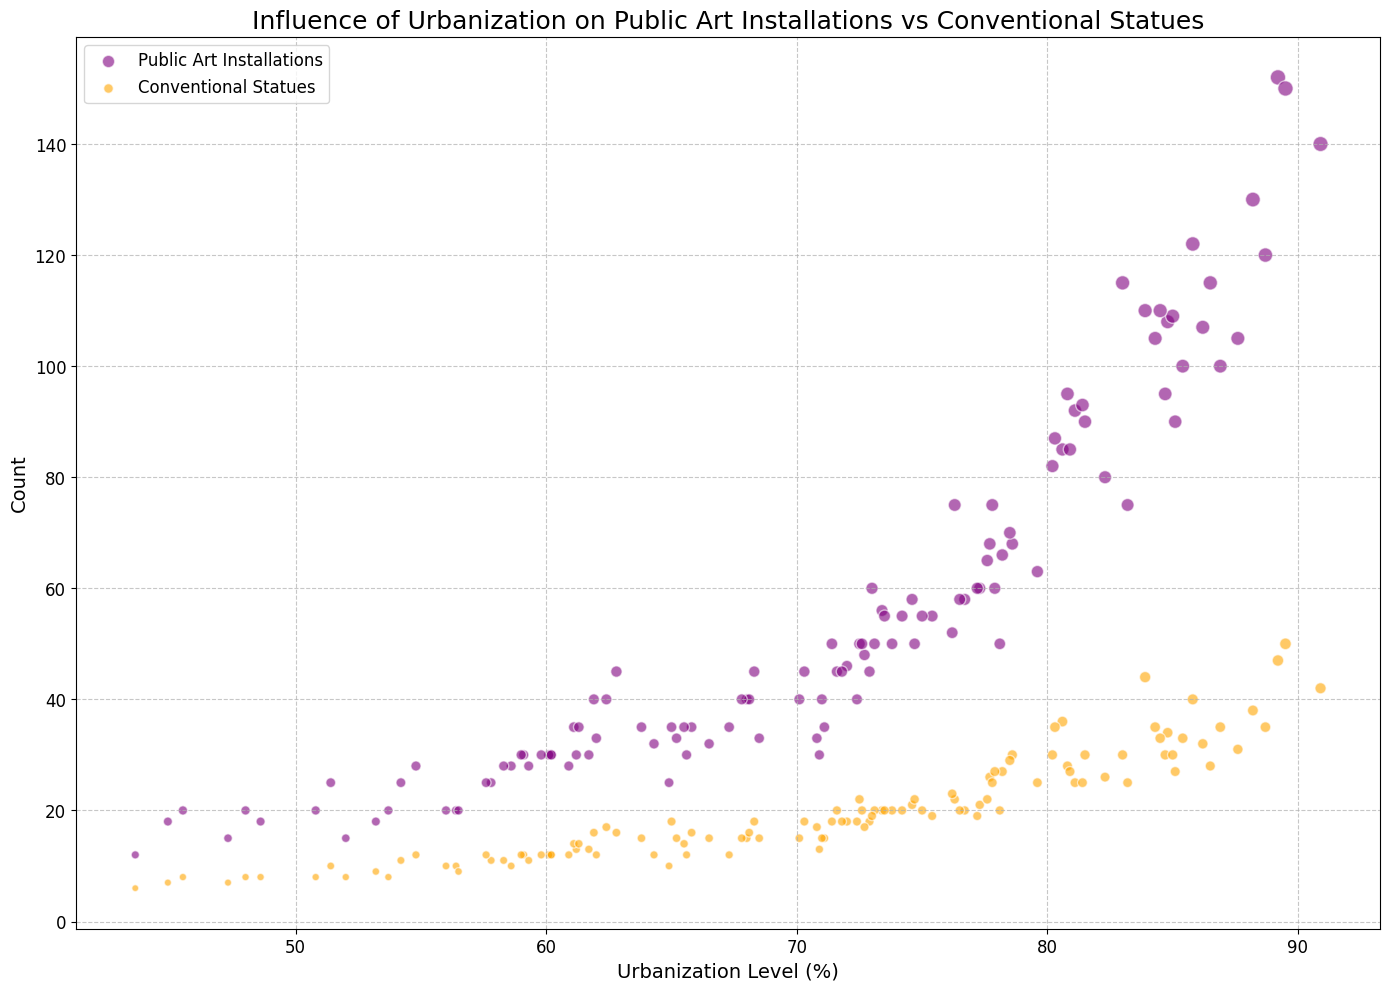What is the general trend between urbanization level and the number of public art installations? Most cities with higher urbanization levels tend to have a higher number of public art installations. For instance, cities like New York and San Francisco show both high urbanization levels and a significant number of public art installations.
Answer: Higher urbanization corresponds to more public art installations Which city has the highest number of conventional statues and what is its urbanization level? Washington DC has the highest number of conventional statues at 50. Its urbanization level is 89.5%.
Answer: Washington DC; 89.5% How do the sizes of the art and statue markers vary with their respective number of installations/statues? The markers' sizes are proportional to the square root of the number of installations/statues. Hence, a higher number results in larger markers. Public art installations markers are purple, and conventional statues markers are orange.
Answer: Proportional to the square root Which city with an urbanization level over 85% has the lowest number of public art installations, and how many does it have? San Diego has the lowest number of public art installations among cities with an urbanization level over 85%, with 90 installations.
Answer: San Diego; 90 Compare New York and Phoenix in terms of urbanization level and the number of public art installations. Which city has a higher urbanization level and more installations? New York has a higher urbanization level (89.2%) and more public art installations (152) compared to Phoenix, which has an urbanization level of 81.1% and 92 installations.
Answer: New York What is the average number of conventional statues in cities with urbanization levels between 80% and 85%? Calculating the average: Philadelphia (36), Dallas (30), San Jose (31), Charlotte (26), Sacramento (25), Long Beach (28), Tampa (27), Richmond (30). Summing these: 36+30+31+26+25+28+27+30 = 233. The average is 233/8 = 29.125.
Answer: 29.125 Which cities have a higher number of public art installations than conventional statues, and what is the visual indicator? Most cities exhibit this trend, indicated by larger purple markers (public art installations) compared to orange markers (conventional statues). Examples include New York, Los Angeles, and Chicago.
Answer: Larger purple markers How does Houston compare to Washington DC regarding the number of public art installations and conventional statues? Houston has 100 public art installations and 33 conventional statues. Washington DC has 150 public art installations and 50 conventional statues. So, Washington DC has more installations and statues than Houston.
Answer: More in Washington DC For cities with urbanization levels below 60%, which city has the highest combined number of public art installations and conventional statues? Combining the numbers for Anchorage, Buffalo, North Las Vegas, Moreno Valley, etc., Anchorage has 28 public art installations and 12 statues, totaling 40, which is the highest combined number below 60% urbanization.
Answer: Anchorage; 40 